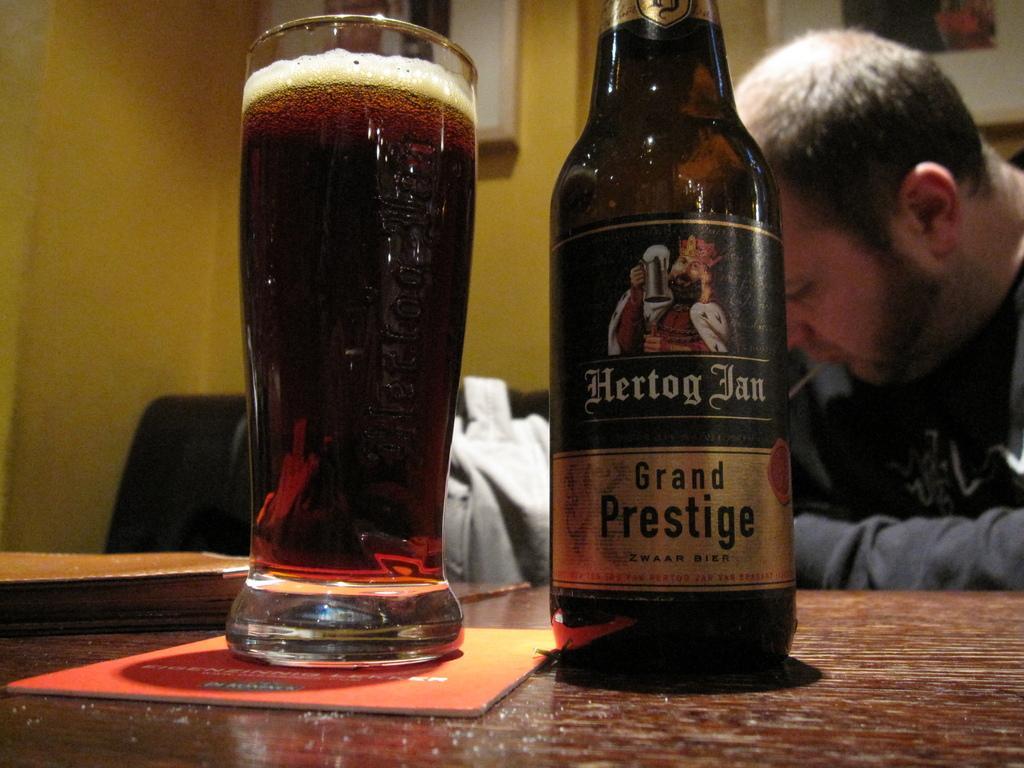In one or two sentences, can you explain what this image depicts? There is a glass and a bottle on the table. This is book. Here we can see a man. On the background there is a yellow colored wall and these are the frames. 